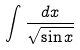Convert formula to latex. <formula><loc_0><loc_0><loc_500><loc_500>\int \frac { d x } { \sqrt { \sin x } }</formula> 